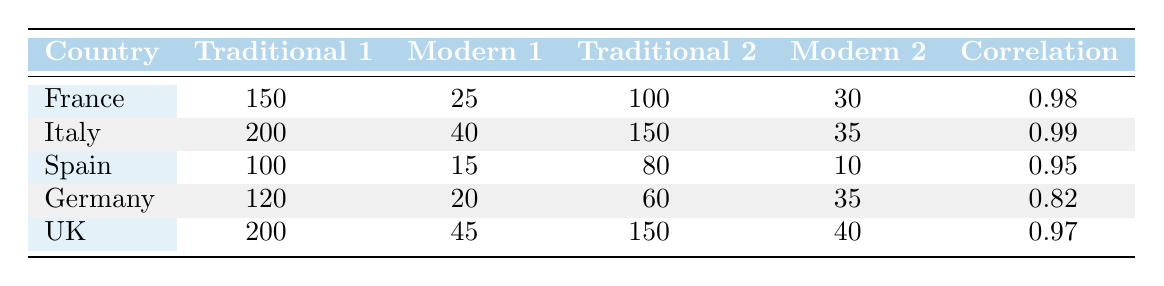What country has the highest number of gothic cathedrals? France has 150 gothic cathedrals, which is higher than the counts for Italy, Spain, Germany, and the United Kingdom.
Answer: France How many neo-classical influenced modern buildings are there in Italy? In Italy, there are 35 modern buildings influenced by neo-classical architecture, which is directly stated in the table under the column for neo-classical influenced modern buildings.
Answer: 35 What is the sum of the gothic influenced modern buildings and neo-classical influenced modern buildings in France? In France, the gothic influenced modern buildings count is 25 and the neo-classical influenced modern buildings count is 30. The sum is calculated as 25 + 30 = 55.
Answer: 55 Is it true that Spain has more mudejar influenced modern buildings than Germany has neo-gothic influenced modern buildings? Spain has 15 mudejar influenced modern buildings, while Germany has only 20 neo-gothic influenced modern buildings. Since 15 is less than 20, the statement is false.
Answer: No Which country shows the strongest correlation between traditional and modern architecture, and what is that correlation value? Italy shows the strongest correlation with a value of 0.99, the highest among all countries in the table, indicating a strong relationship between traditional and modern architectures.
Answer: Italy, 0.99 What is the average count of gothic influenced modern buildings across all countries listed? The total gothic influenced modern buildings count for all countries is 25 (France) + 40 (Italy) + 10 (Spain) + 20 (Germany) + 45 (UK) = 140. There are 5 countries, so the average is 140/5 = 28.
Answer: 28 Does the United Kingdom have more Victorian influenced modern buildings than the total of baroque influenced modern buildings in Germany? The United Kingdom has 45 Victorian influenced modern buildings, while Germany has 10 baroque influenced modern buildings. Since 45 is greater than 10, the statement is true.
Answer: Yes If we rank countries based on the number of neo-classical influenced modern buildings, which country comes second? The countries rank as follows based on neo-classical influenced modern buildings: France (30), Italy (35), then Germany (not applicable as it doesn’t have neo-classical influence but rather Bauhaus). So, it’s Italy (35) coming second after France (30).
Answer: Italy 